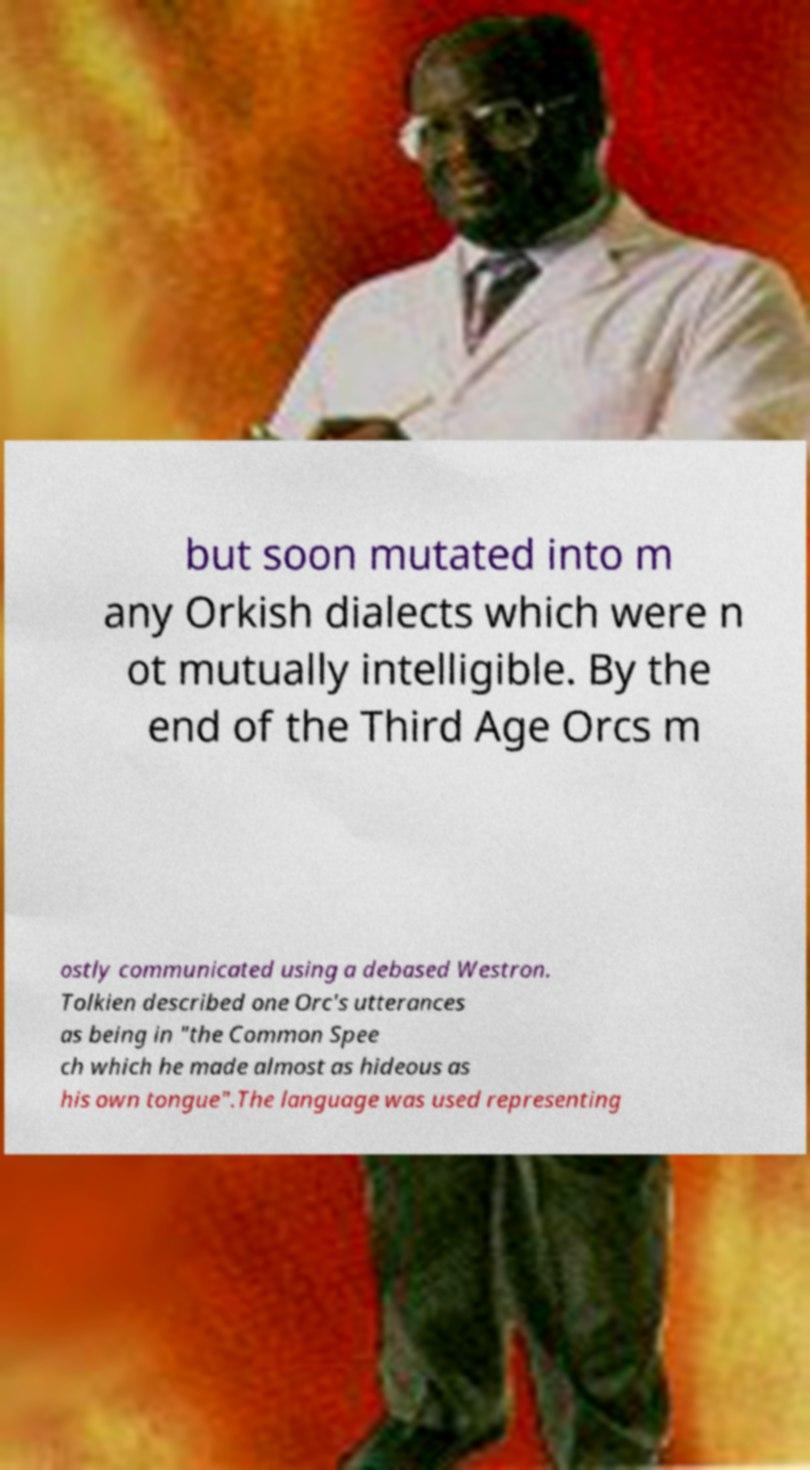Can you read and provide the text displayed in the image?This photo seems to have some interesting text. Can you extract and type it out for me? but soon mutated into m any Orkish dialects which were n ot mutually intelligible. By the end of the Third Age Orcs m ostly communicated using a debased Westron. Tolkien described one Orc's utterances as being in "the Common Spee ch which he made almost as hideous as his own tongue".The language was used representing 